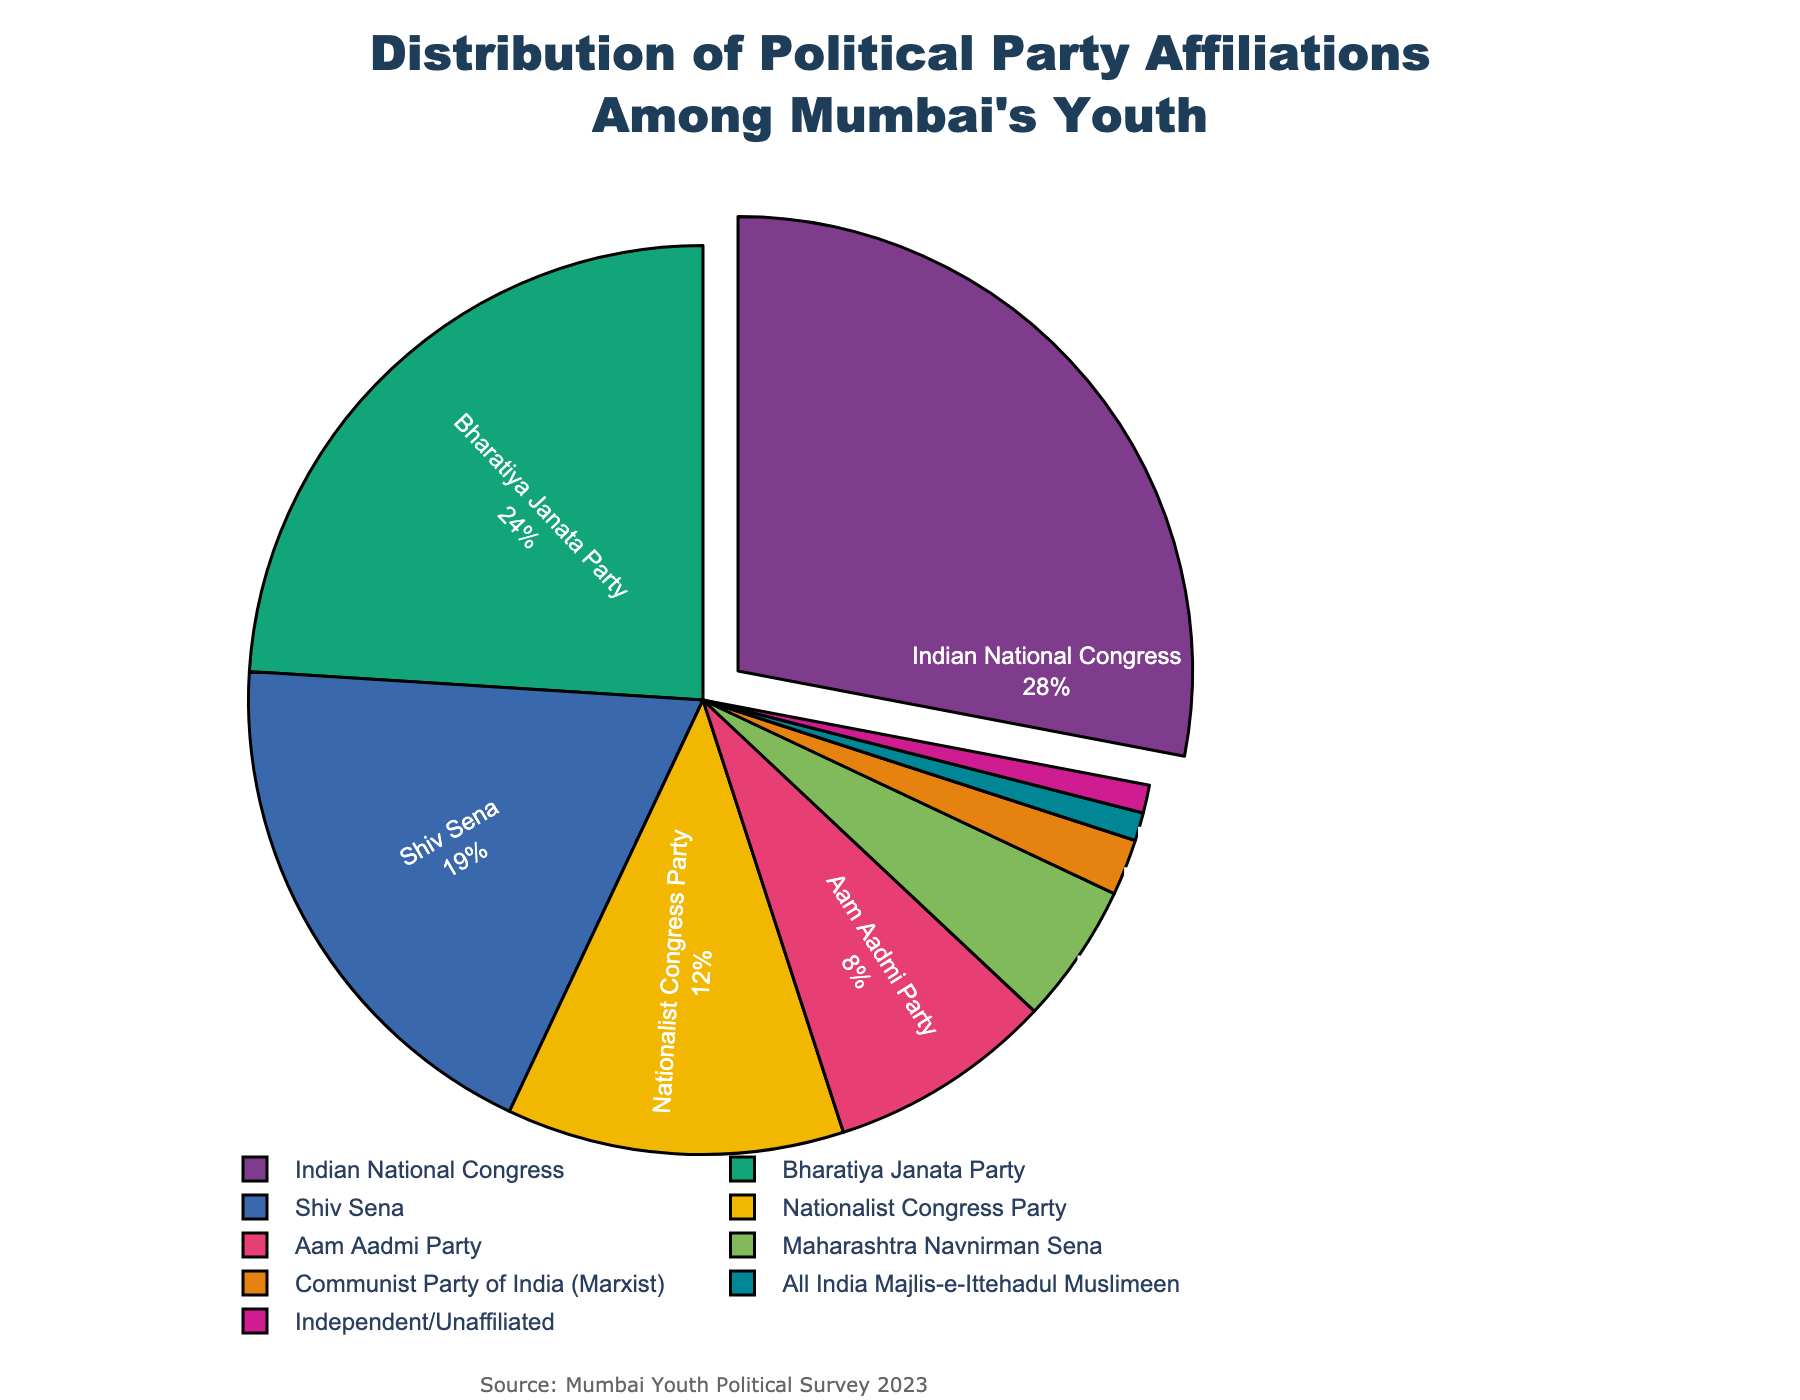What is the percentage of youth affiliated with the Shiv Sena? To find the percentage of youth affiliated with Shiv Sena, look at the section of the pie chart labeled "Shiv Sena". The corresponding label indicates the percentage.
Answer: 19% Which party has the smallest representation among Mumbai's youth? Identify the smallest slice in the pie chart and check the associated label.
Answer: All India Majlis-e-Ittehadul Muslimeen Which party has the highest percentage of affiliations and how much is it? Find the largest slice in the pie chart and read the corresponding label.
Answer: Indian National Congress, 28% By how much does the Bharatiya Janata Party's percentage exceed that of the MNS? Look at the percentages for both Bharatiya Janata Party (24%) and Maharashtra Navnirman Sena (5%). Subtract the percentage of MNS from BJP's percentage: 24 - 5.
Answer: 19% What is the combined percentage of youth affiliated with the Aam Aadmi Party and the Nationalist Congress Party? Look at the percentages for Aam Aadmi Party (8%) and Nationalist Congress Party (12%). Add the two percentages together: 8 + 12.
Answer: 20% Which two parties have an equal percentage of youth affiliations? Identify the slices in the pie chart that appear equal and confirm their values.
Answer: Independent/Unaffiliated and All India Majlis-e-Ittehadul Muslimeen How does the percentage affiliation of the Indian National Congress compare to that of the Aam Aadmi Party? Compare the percentages next to Indian National Congress (28%) and Aam Aadmi Party (8%). Indian National Congress has a higher percentage than the Aam Aadmi Party.
Answer: Indian National Congress is higher If you combine the percentage of youth affiliated with Maharashtra Navnirman Sena and Communist Party of India (Marxist), how does it compare to Nationalist Congress Party's percentage? Add the percentages for Maharashtra Navnirman Sena (5%) and Communist Party of India (Marxist) (2%) to get 5 + 2 = 7%. Compare 7% with Nationalist Congress Party's percentage (12%).
Answer: Less than Nationalist Congress Party Which party's percentage is closest to that of Bharatiya Janata Party? Compare the percentages and find the one closest to Bharatiya Janata Party (24%). Shiv Sena has a percentage of 19%, which is the closest.
Answer: Shiv Sena What is the sum of percentages for all parties except the Indian National Congress and Bharatiya Janata Party? Subtract the percentages of the Indian National Congress (28%) and Bharatiya Janata Party (24%) from 100%: 100 - 28 - 24 = 48%.
Answer: 48% 